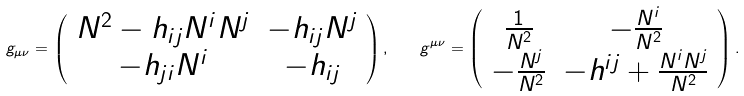Convert formula to latex. <formula><loc_0><loc_0><loc_500><loc_500>g _ { \mu \nu } = \left ( \begin{array} { c c } N ^ { 2 } - h _ { i j } N ^ { i } N ^ { j } & - h _ { i j } N ^ { j } \\ - h _ { j i } N ^ { i } & - h _ { i j } \end{array} \right ) , \quad g ^ { \mu \nu } = \left ( \begin{array} { c c } \frac { 1 } { N ^ { 2 } } & - \frac { N ^ { i } } { N ^ { 2 } } \\ - \frac { N ^ { j } } { N ^ { 2 } } & - h ^ { i j } + \frac { N ^ { i } N ^ { j } } { N ^ { 2 } } \end{array} \right ) .</formula> 